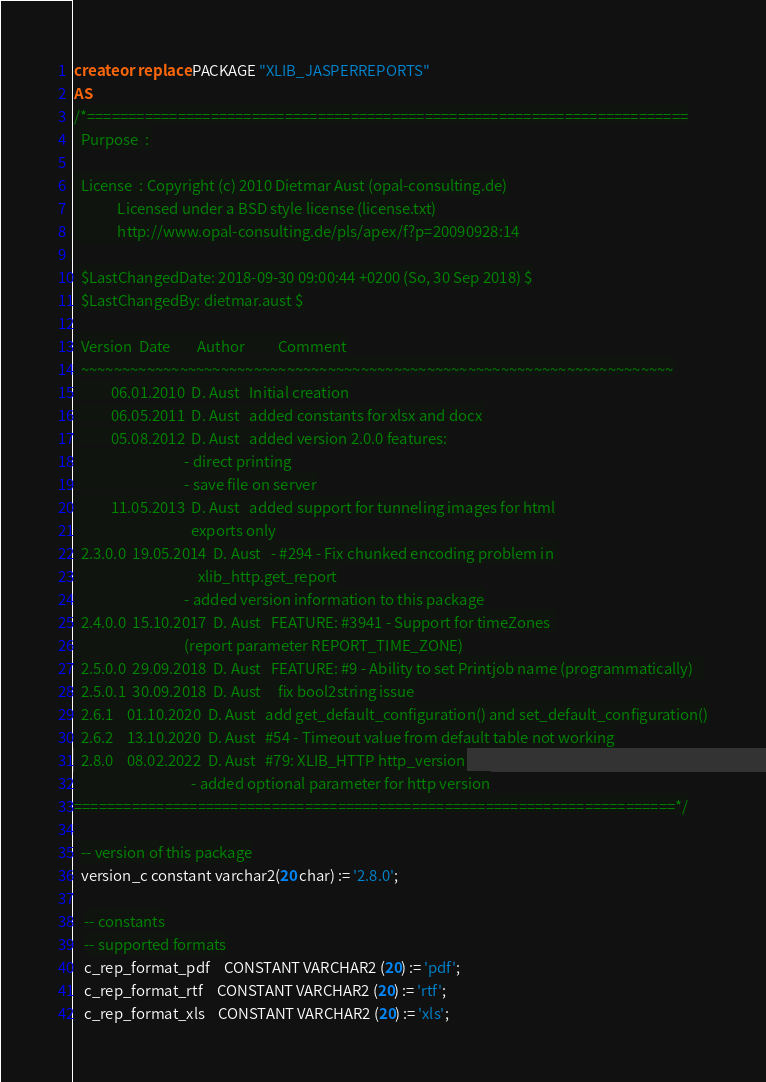<code> <loc_0><loc_0><loc_500><loc_500><_SQL_>create or replace PACKAGE "XLIB_JASPERREPORTS"
AS
/*=========================================================================
  Purpose  : 

  License  : Copyright (c) 2010 Dietmar Aust (opal-consulting.de)
             Licensed under a BSD style license (license.txt)
             http://www.opal-consulting.de/pls/apex/f?p=20090928:14

  $LastChangedDate: 2018-09-30 09:00:44 +0200 (So, 30 Sep 2018) $
  $LastChangedBy: dietmar.aust $

  Version  Date        Author          Comment
  ~~~~~~~~~~~~~~~~~~~~~~~~~~~~~~~~~~~~~~~~~~~~~~~~~~~~~~~~~~~~~~~~~~~~~~~~
           06.01.2010  D. Aust   Initial creation
           06.05.2011  D. Aust   added constants for xlsx and docx
           05.08.2012  D. Aust   added version 2.0.0 features:
                                 - direct printing
                                 - save file on server
           11.05.2013  D. Aust   added support for tunneling images for html
                                   exports only
  2.3.0.0  19.05.2014  D. Aust   - #294 - Fix chunked encoding problem in 
                                     xlib_http.get_report
                                 - added version information to this package
  2.4.0.0  15.10.2017  D. Aust   FEATURE: #3941 - Support for timeZones 
                                 (report parameter REPORT_TIME_ZONE)
  2.5.0.0  29.09.2018  D. Aust   FEATURE: #9 - Ability to set Printjob name (programmatically)   
  2.5.0.1  30.09.2018  D. Aust     fix bool2string issue
  2.6.1    01.10.2020  D. Aust   add get_default_configuration() and set_default_configuration()
  2.6.2    13.10.2020  D. Aust   #54 - Timeout value from default table not working
  2.8.0    08.02.2022  D. Aust   #79: XLIB_HTTP http_version
                                   - added optional parameter for http version
=========================================================================*/

  -- version of this package
  version_c constant varchar2(20 char) := '2.8.0';   

   -- constants
   -- supported formats
   c_rep_format_pdf    CONSTANT VARCHAR2 (20) := 'pdf';
   c_rep_format_rtf    CONSTANT VARCHAR2 (20) := 'rtf';
   c_rep_format_xls    CONSTANT VARCHAR2 (20) := 'xls';</code> 